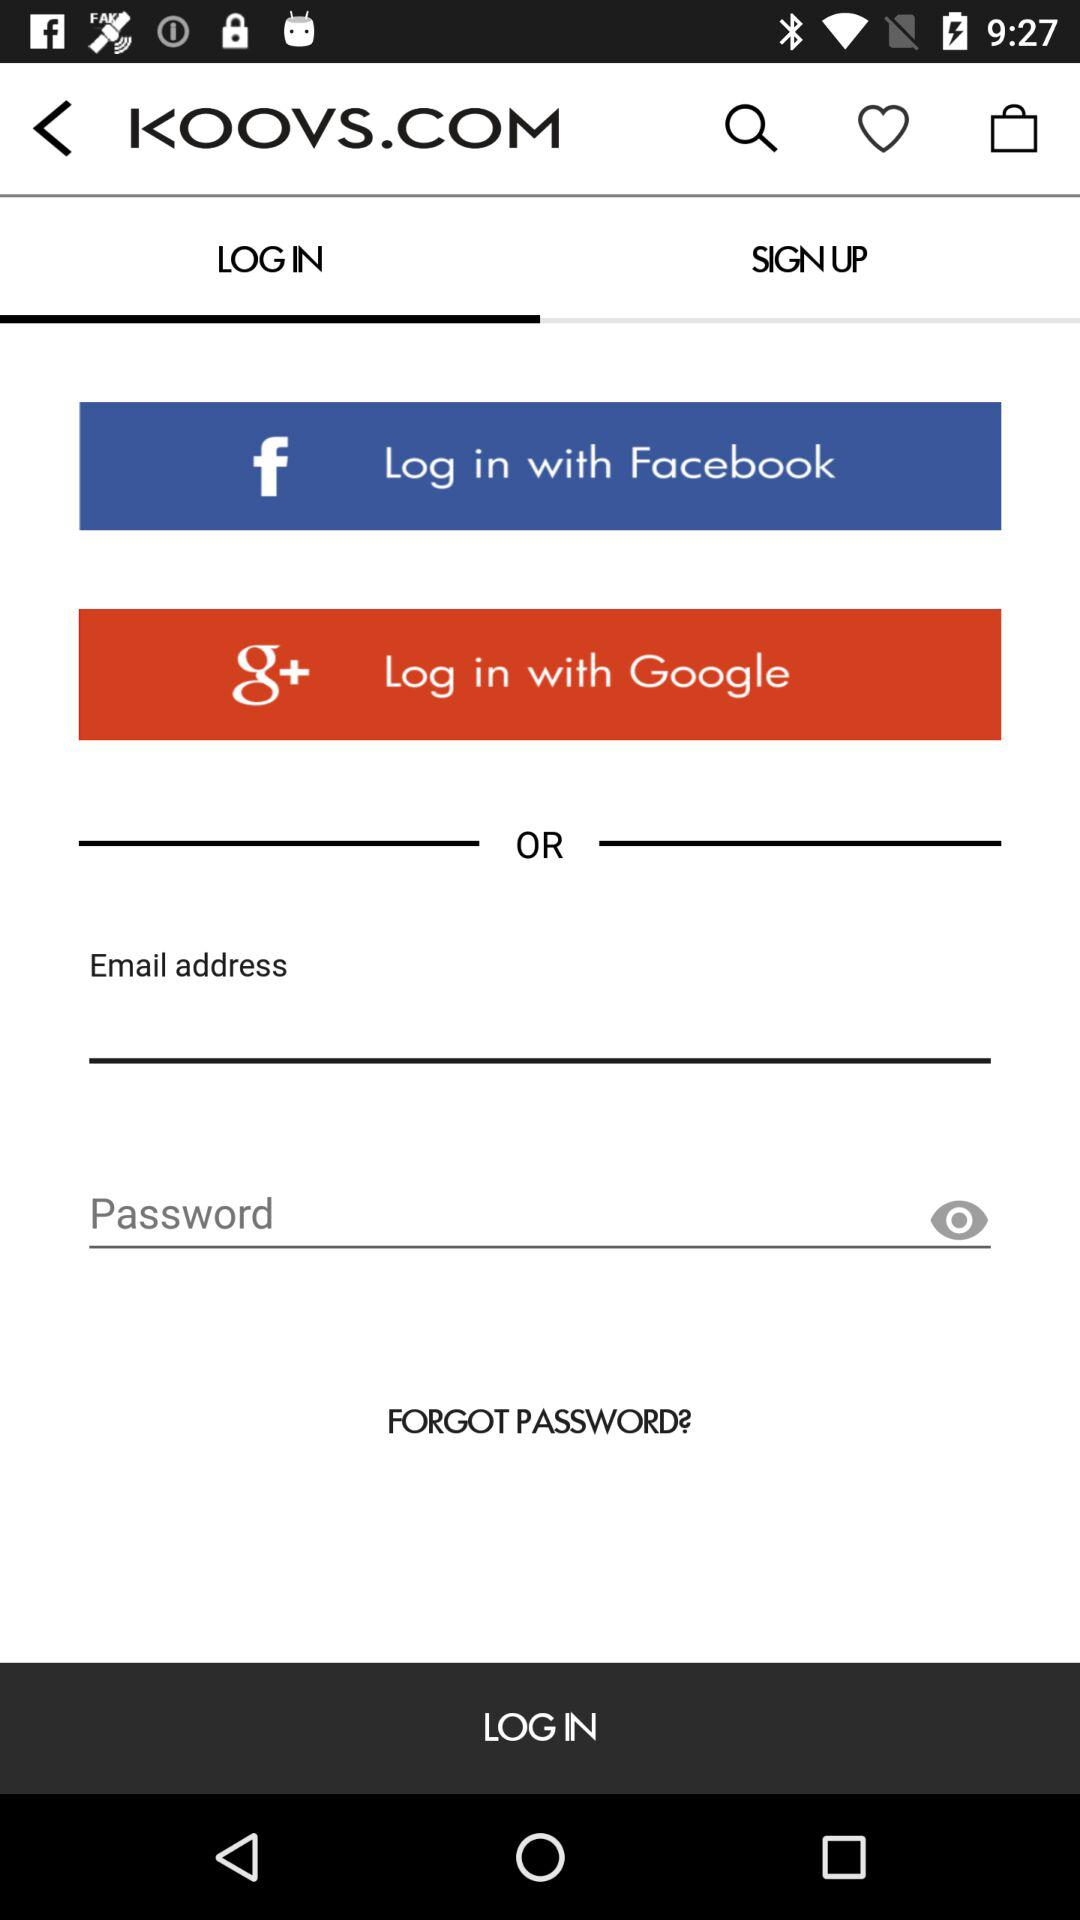What is the selected tab? The selected tab is "LOG IN". 